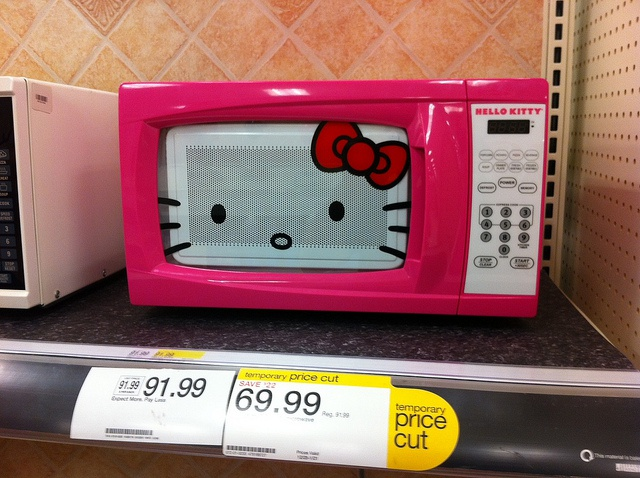Describe the objects in this image and their specific colors. I can see microwave in tan, darkgray, and brown tones and microwave in tan, salmon, brown, and black tones in this image. 